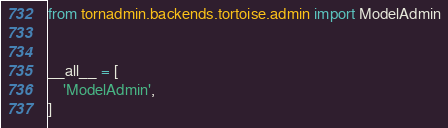Convert code to text. <code><loc_0><loc_0><loc_500><loc_500><_Python_>from tornadmin.backends.tortoise.admin import ModelAdmin


__all__ = [
    'ModelAdmin',
]
</code> 